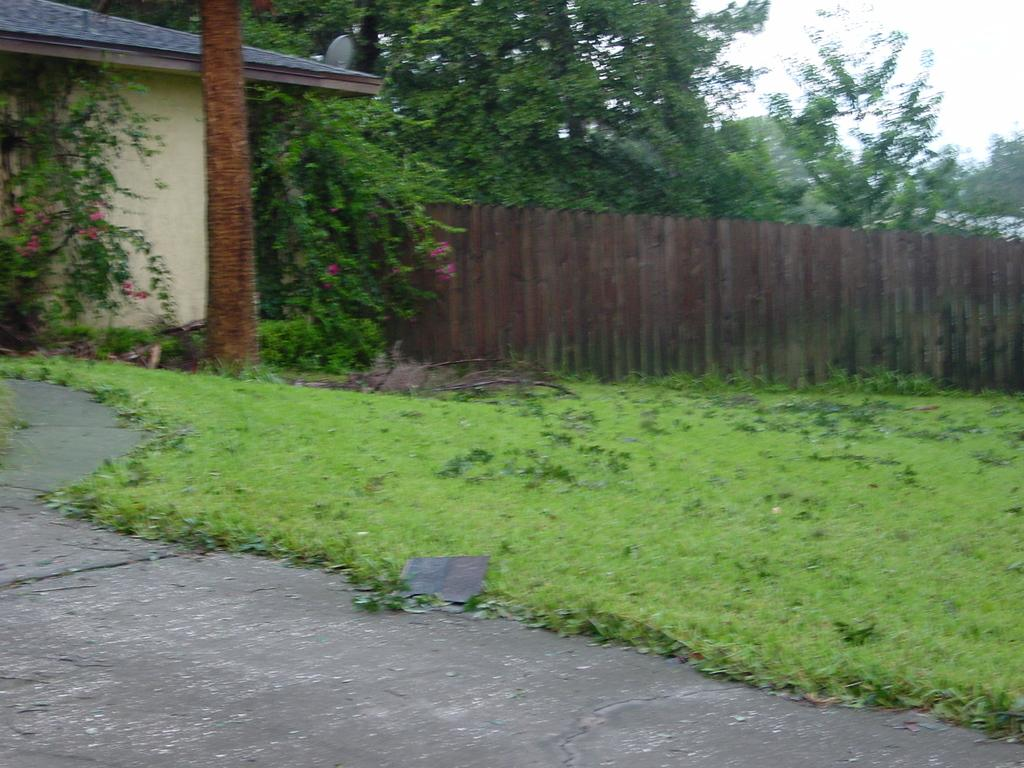What is the main feature in the foreground of the image? There is a path in the front of the image. Where is the path located in relation to the other elements in the image? The path is in the front of the image. What type of ground is visible in the background of the image? There is grass ground in the background of the image. What other natural elements can be seen in the background of the image? There are trees in the background of the image. What man-made structures are present in the image? There is a wall and a building on the left side of the image. How many fish can be seen swimming in the water near the path? There are no fish or water visible in the image; it features a path with a grass ground and trees in the background. 